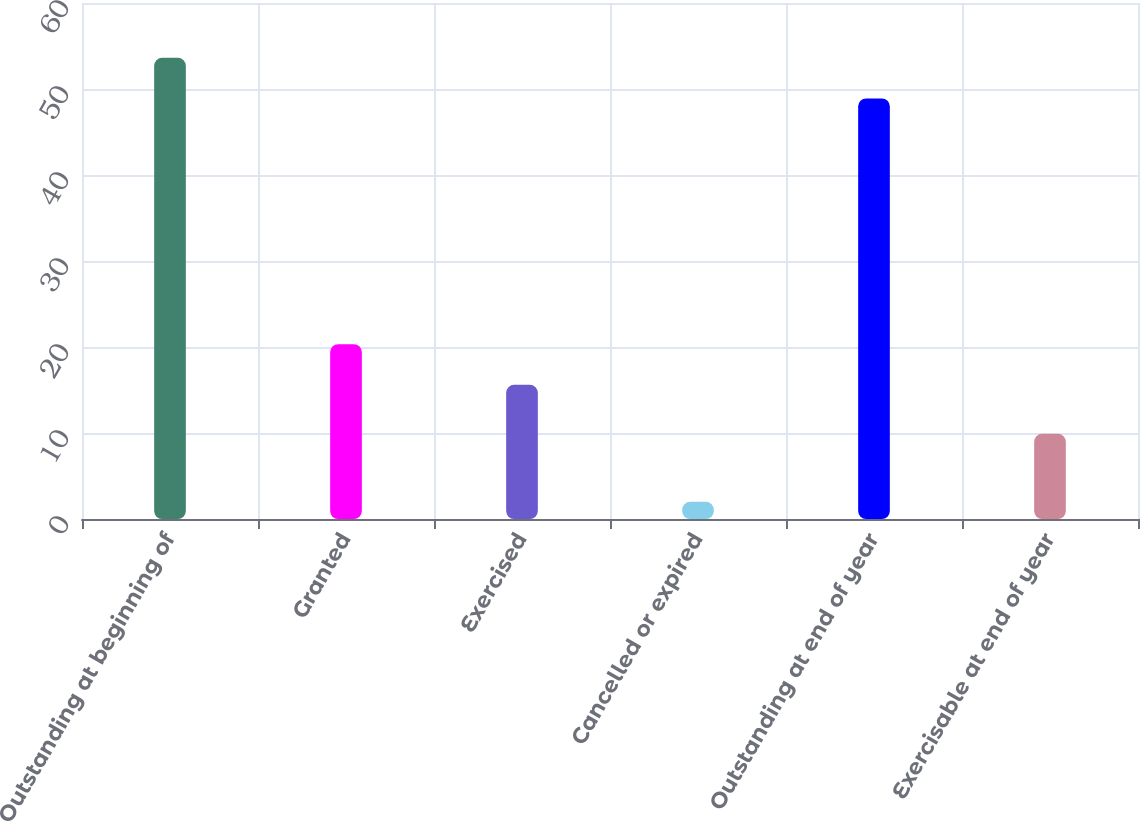Convert chart to OTSL. <chart><loc_0><loc_0><loc_500><loc_500><bar_chart><fcel>Outstanding at beginning of<fcel>Granted<fcel>Exercised<fcel>Cancelled or expired<fcel>Outstanding at end of year<fcel>Exercisable at end of year<nl><fcel>53.63<fcel>20.33<fcel>15.6<fcel>2<fcel>48.9<fcel>9.9<nl></chart> 